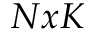Convert formula to latex. <formula><loc_0><loc_0><loc_500><loc_500>N x K</formula> 